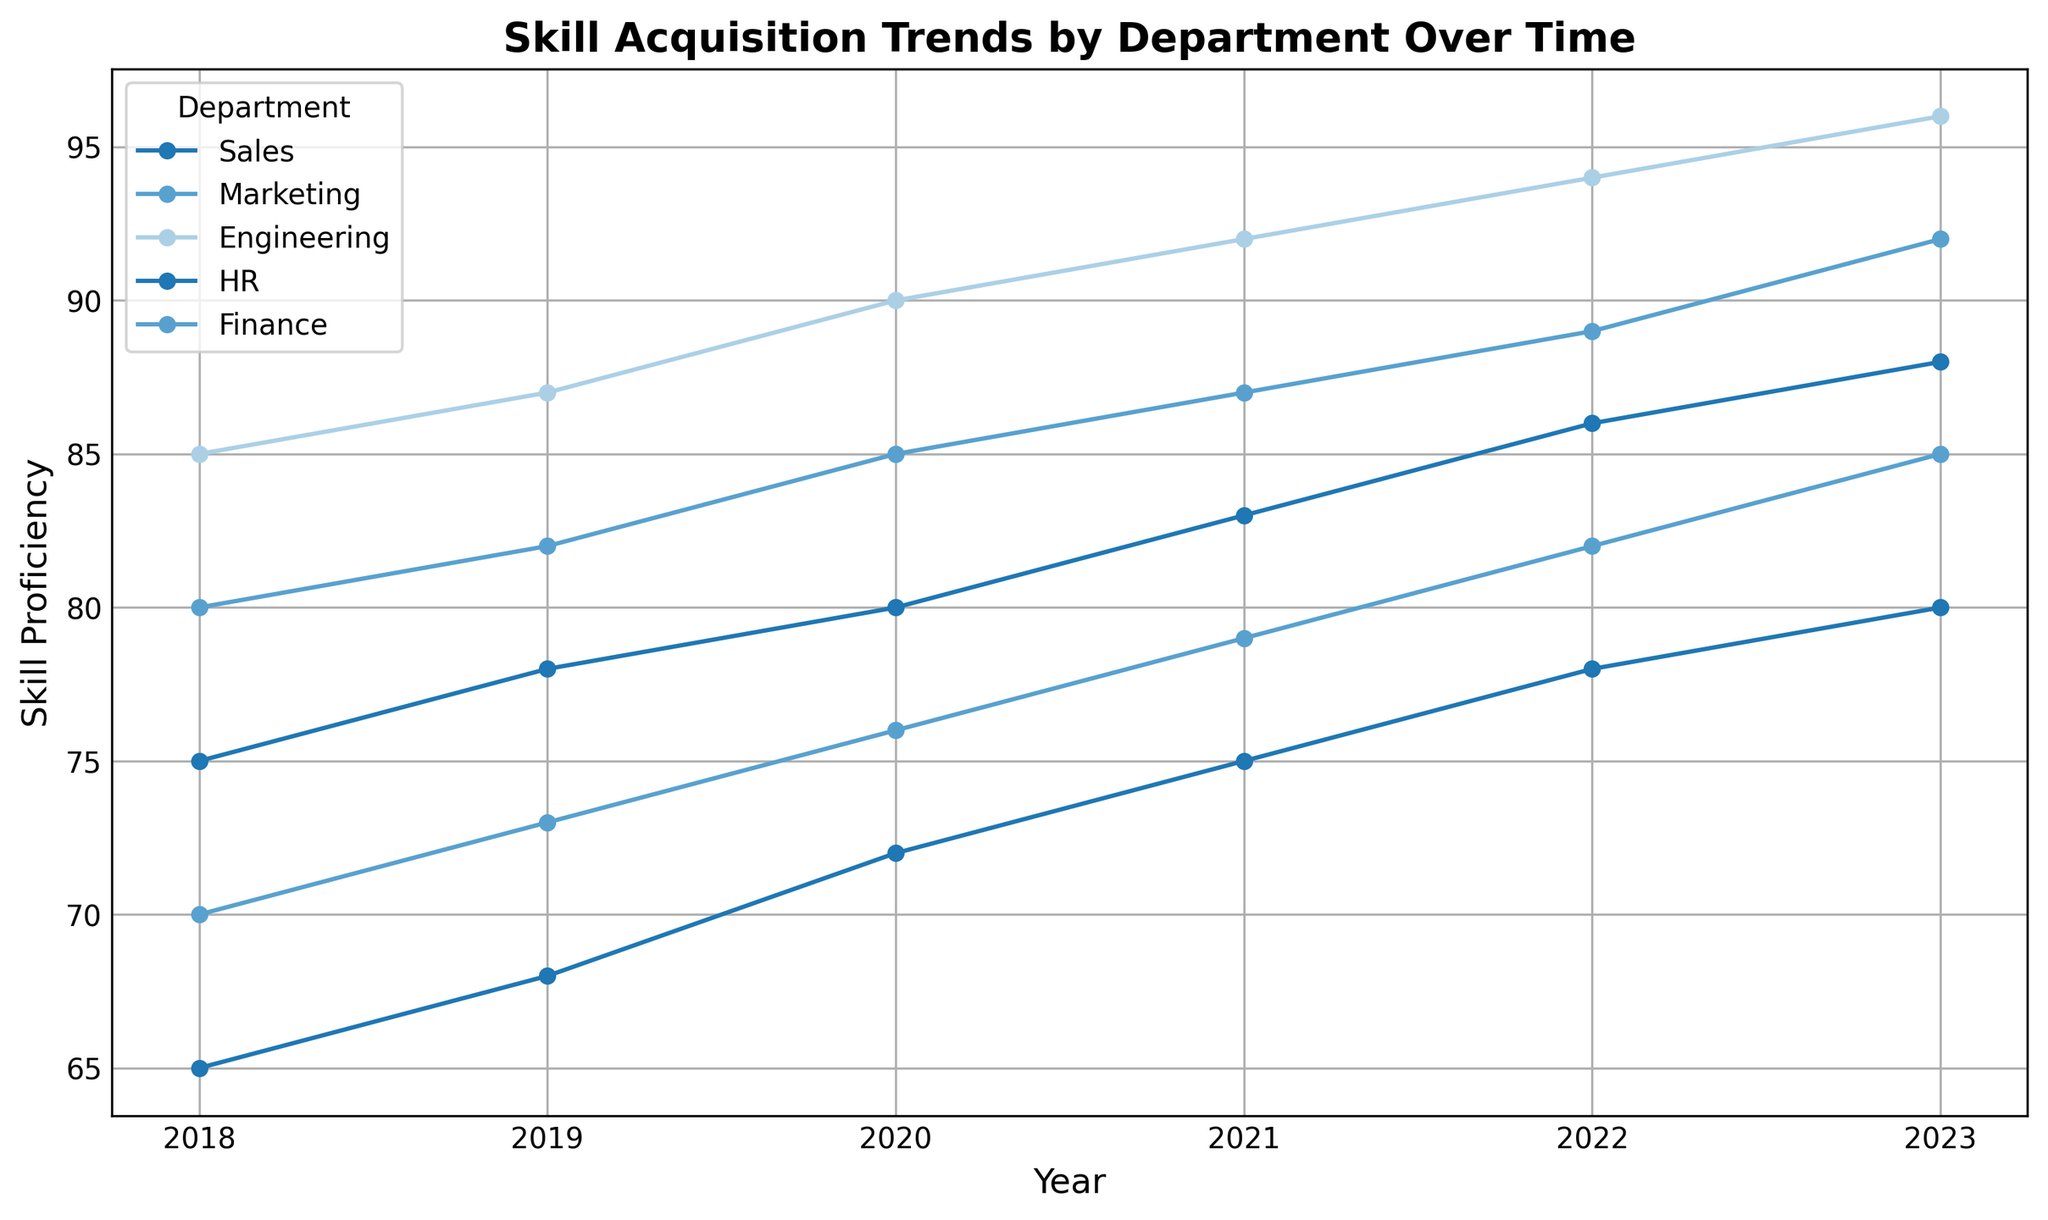What is the trend in skill proficiency for the Engineering department from 2018 to 2023? To determine the trend in skill proficiency, observe the line representing the Engineering department from 2018 to 2023. It starts at 85 in 2018 and increases steadily each year, reaching 96 in 2023.
Answer: Increasing Which department had the highest skill proficiency in 2021, and what was the value? Look for the highest peak on the 2021 vertical line and identify the corresponding department. The highest peak is with the Engineering department with a value of 92.
Answer: Engineering, 92 Compare the skill proficiency growth for Sales and Marketing departments from 2018 to 2023. Which department had a higher increase, and by how much? Calculate the increase for both departments by subtracting the 2018 values from the 2023 values. For Sales: 80 - 65 = 15; for Marketing: 85 - 70 = 15. Both departments had the same increase in skill proficiency.
Answer: Both departments, 15 Which department showed the most consistent increase in skill proficiency over the years? Consistency indicates a steady and uniform increase. By observing the slope and uniformity of the lines, the Sales department exhibits the most consistent increase without any dips (steady growth from 65 to 80).
Answer: Sales Among all departments, which one showed the least improvement from 2018 to 2023? Calculate the improvement for each department by subtracting the 2018 values from the 2023 values. Engineering: 96-85=11, Sales: 80-65=15, Marketing: 85-70=15, HR: 88-75=13, Finance: 92-80=12. Engineering showed the least improvement with an increase of 11 points.
Answer: Engineering How does the skill proficiency of the HR department in 2022 compare to that in 2021? Find the skill proficiency values for the HR department in 2021 and 2022 and compare them directly. In 2021, HR was at 83; in 2022, HR was at 86, showing an increase.
Answer: Increased What is the average skill proficiency of the Finance department over the entire period (2018-2023)? Calculate the average by summing the Finance department's skill proficiency values over the years and dividing by the number of years. (80+82+85+87+89+92)/6 = 515/6 = 85.83
Answer: 85.83 Which year did the Marketing department achieve an 85 skill proficiency? Look for the point where the Marketing department's line hits the 85 mark on the proficiency scale. This occurs in the year 2023.
Answer: 2023 Compare the skill proficiency of HR in 2018 to the skill proficiency of Sales in 2020. Which is higher, and by how much? Find the values: HR in 2018 is 75; Sales in 2020 is 72. Subtract to find the difference. 75 - 72 = 3. HR in 2018 is higher by 3 points.
Answer: HR, by 3 points 